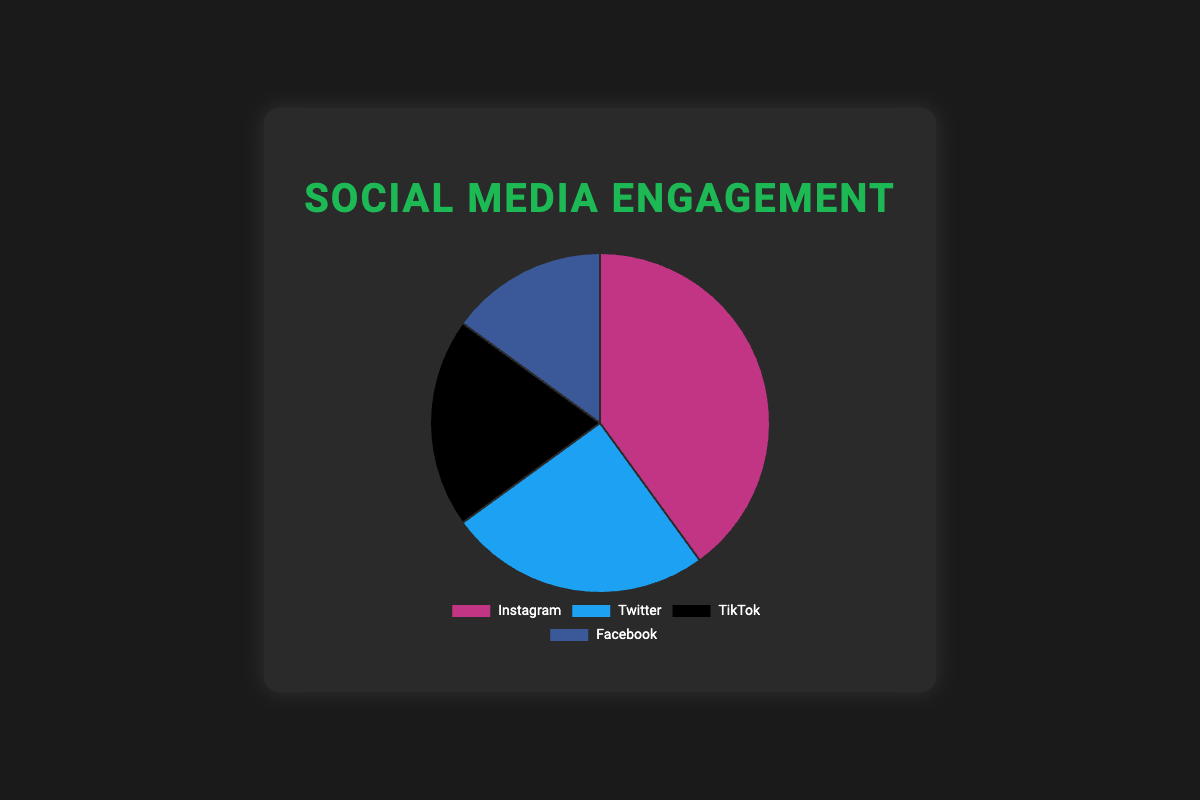What percentage of social media engagement is attributed to TikTok? The pie chart shows the engagement percentage for each platform. According to the chart, TikTok accounts for 20% of the social media engagement.
Answer: 20% Which social media platform has the highest engagement percentage? By looking at the pie chart, Instagram has the largest section, indicating the highest engagement percentage of 40%.
Answer: Instagram How much larger is the engagement percentage for Instagram compared to Facebook? Instagram's engagement is 40%, and Facebook's engagement is 15%. The difference is 40% - 15% = 25%.
Answer: 25% What is the combined engagement percentage for Twitter and Facebook? Twitter has an engagement percentage of 25%, and Facebook has 15%. Adding them together gives 25% + 15% = 40%.
Answer: 40% If you combined the engagement percentages of Instagram and TikTok, how does this compare to the combined engagement percentages of Twitter and Facebook? Instagram and TikTok together have 40% + 20% = 60%. Twitter and Facebook together have 25% + 15% = 40%. Comparing the two, 60% is greater than 40%.
Answer: Instagram and TikTok combined are greater Which platform has the second highest engagement percentage? The pie chart shows that after Instagram's 40%, Twitter has the next largest segment with 25%.
Answer: Twitter What is the difference in engagement percentage between the two lowest-performing platforms? The lowest-performing platforms are TikTok at 20% and Facebook at 15%. The difference is 20% - 15% = 5%.
Answer: 5% Identify the platform represented by the black color in the pie chart and state its engagement percentage. The black color corresponds to TikTok, and its engagement percentage is 20%.
Answer: TikTok, 20% Arrange the platforms from highest to lowest engagement percentage. From the pie chart: Instagram (40%), Twitter (25%), TikTok (20%), Facebook (15%).
Answer: Instagram, Twitter, TikTok, Facebook 